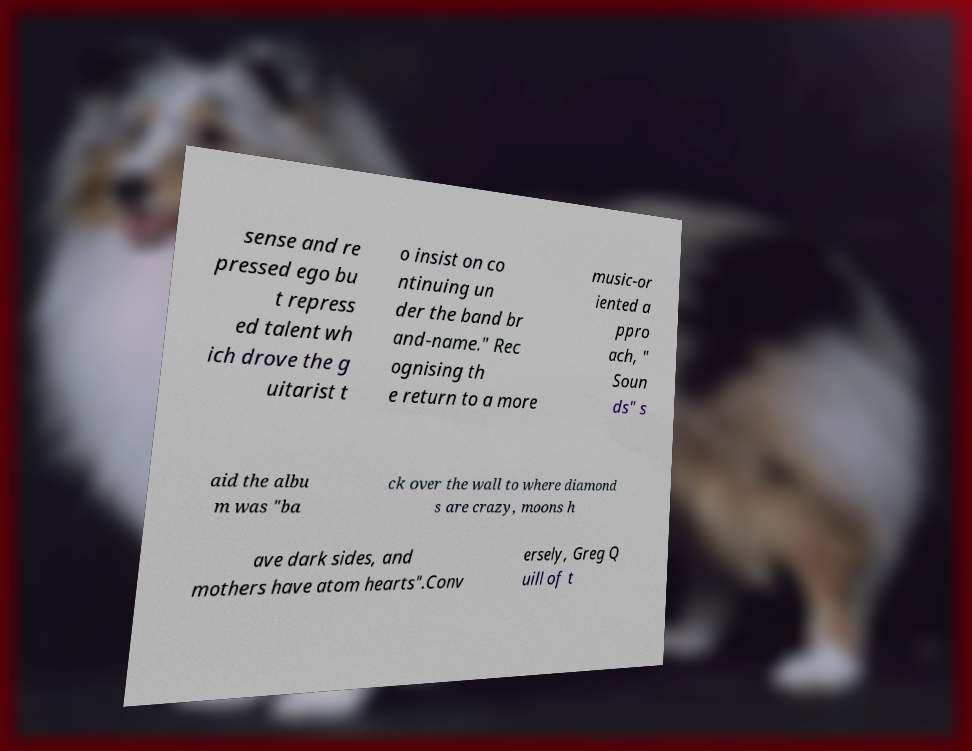What messages or text are displayed in this image? I need them in a readable, typed format. sense and re pressed ego bu t repress ed talent wh ich drove the g uitarist t o insist on co ntinuing un der the band br and-name." Rec ognising th e return to a more music-or iented a ppro ach, " Soun ds" s aid the albu m was "ba ck over the wall to where diamond s are crazy, moons h ave dark sides, and mothers have atom hearts".Conv ersely, Greg Q uill of t 